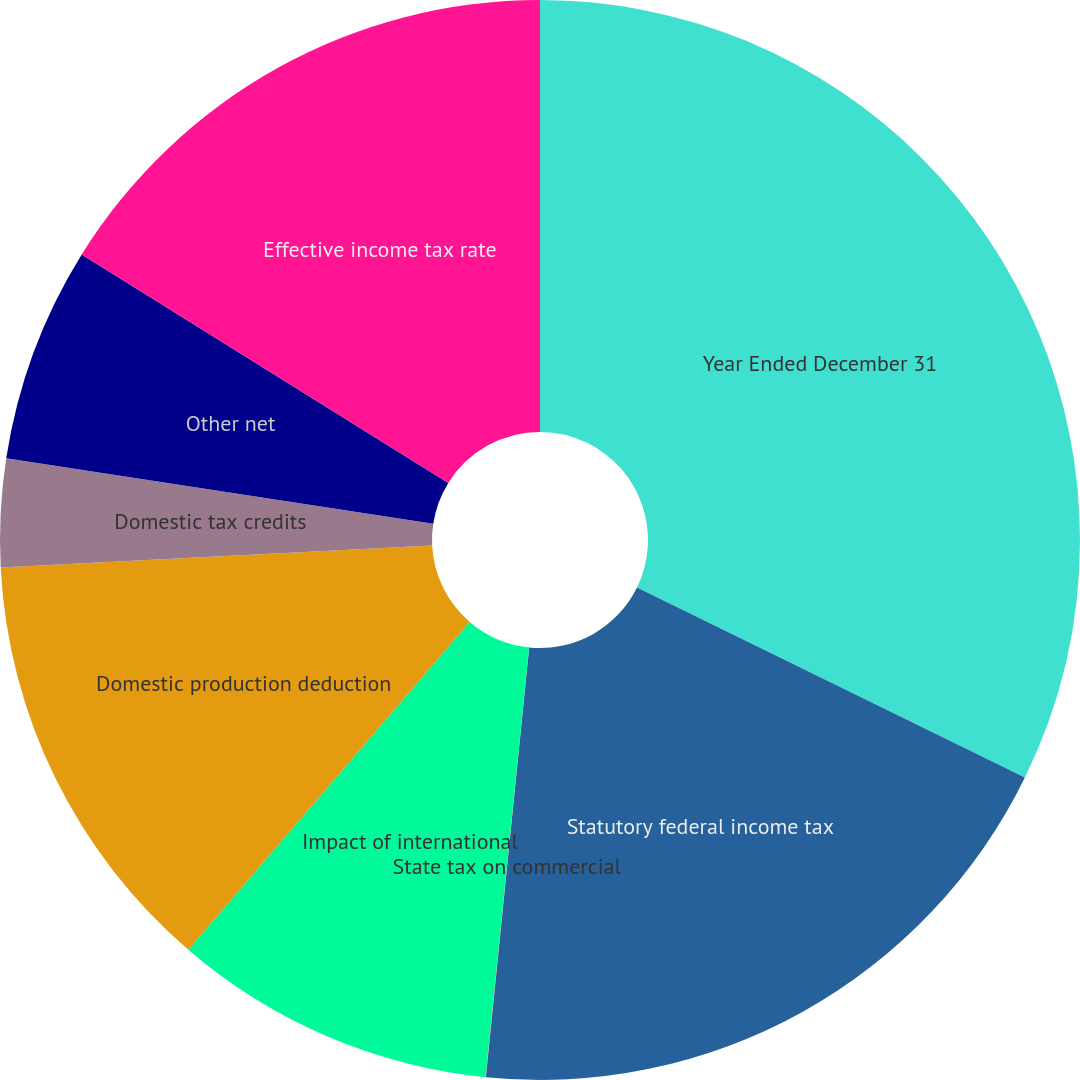Convert chart. <chart><loc_0><loc_0><loc_500><loc_500><pie_chart><fcel>Year Ended December 31<fcel>Statutory federal income tax<fcel>State tax on commercial<fcel>Impact of international<fcel>Domestic production deduction<fcel>Domestic tax credits<fcel>Other net<fcel>Effective income tax rate<nl><fcel>32.25%<fcel>19.35%<fcel>0.01%<fcel>9.68%<fcel>12.9%<fcel>3.23%<fcel>6.45%<fcel>16.13%<nl></chart> 